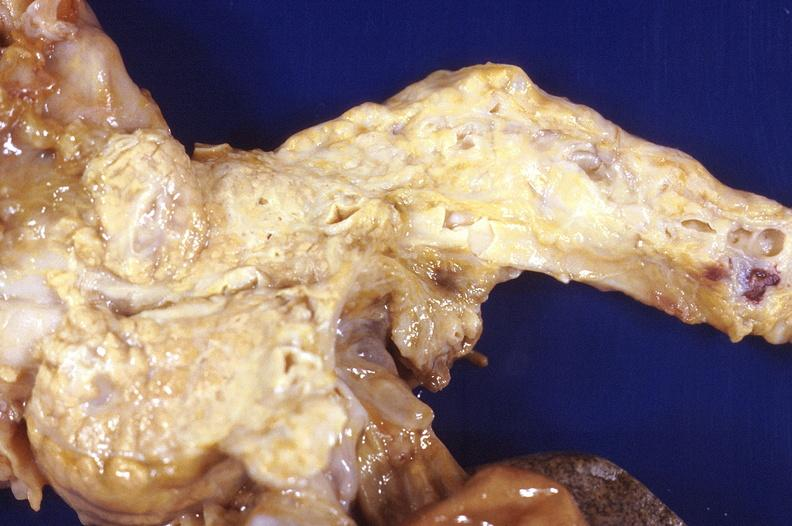does hemorrhage in newborn show prostatic hyperplasia?
Answer the question using a single word or phrase. No 